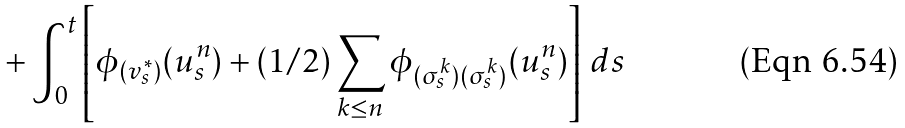<formula> <loc_0><loc_0><loc_500><loc_500>+ \int _ { 0 } ^ { t } \left [ \phi _ { ( v ^ { * } _ { s } ) } ( u ^ { n } _ { s } ) + ( 1 / 2 ) \sum _ { k \leq n } \phi _ { ( \sigma ^ { k } _ { s } ) ( \sigma ^ { k } _ { s } ) } ( u ^ { n } _ { s } ) \right ] \, d s</formula> 